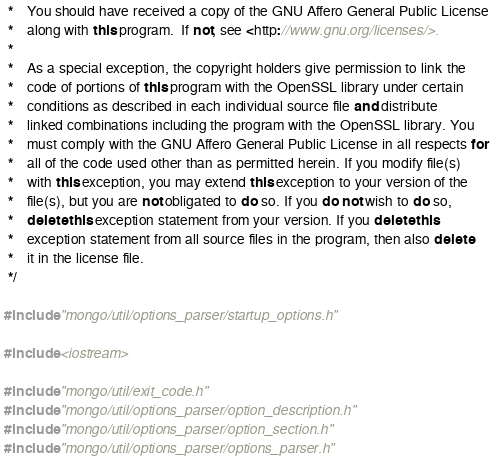<code> <loc_0><loc_0><loc_500><loc_500><_C++_> *    You should have received a copy of the GNU Affero General Public License
 *    along with this program.  If not, see <http://www.gnu.org/licenses/>.
 *
 *    As a special exception, the copyright holders give permission to link the
 *    code of portions of this program with the OpenSSL library under certain
 *    conditions as described in each individual source file and distribute
 *    linked combinations including the program with the OpenSSL library. You
 *    must comply with the GNU Affero General Public License in all respects for
 *    all of the code used other than as permitted herein. If you modify file(s)
 *    with this exception, you may extend this exception to your version of the
 *    file(s), but you are not obligated to do so. If you do not wish to do so,
 *    delete this exception statement from your version. If you delete this
 *    exception statement from all source files in the program, then also delete
 *    it in the license file.
 */

#include "mongo/util/options_parser/startup_options.h"

#include <iostream>

#include "mongo/util/exit_code.h"
#include "mongo/util/options_parser/option_description.h"
#include "mongo/util/options_parser/option_section.h"
#include "mongo/util/options_parser/options_parser.h"</code> 